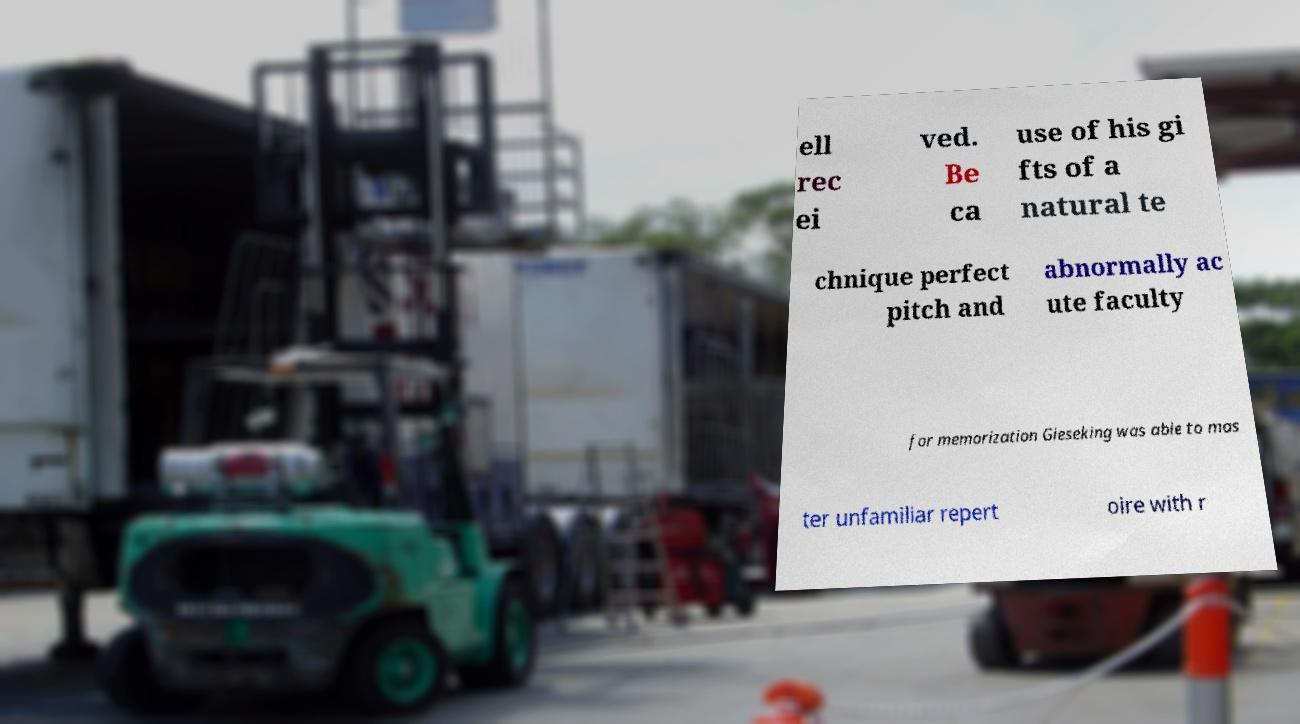Could you extract and type out the text from this image? ell rec ei ved. Be ca use of his gi fts of a natural te chnique perfect pitch and abnormally ac ute faculty for memorization Gieseking was able to mas ter unfamiliar repert oire with r 